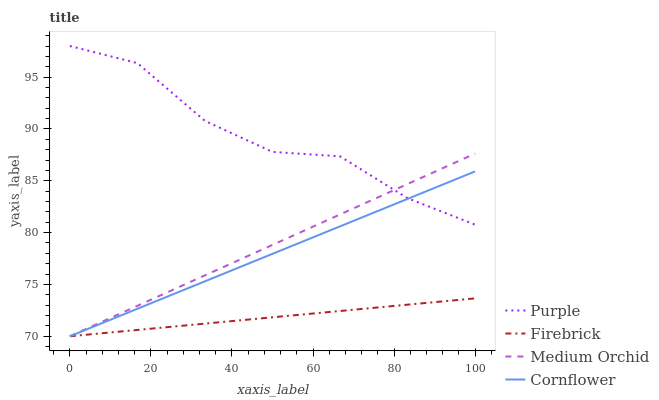Does Firebrick have the minimum area under the curve?
Answer yes or no. Yes. Does Purple have the maximum area under the curve?
Answer yes or no. Yes. Does Cornflower have the minimum area under the curve?
Answer yes or no. No. Does Cornflower have the maximum area under the curve?
Answer yes or no. No. Is Cornflower the smoothest?
Answer yes or no. Yes. Is Purple the roughest?
Answer yes or no. Yes. Is Firebrick the smoothest?
Answer yes or no. No. Is Firebrick the roughest?
Answer yes or no. No. Does Cornflower have the lowest value?
Answer yes or no. Yes. Does Purple have the highest value?
Answer yes or no. Yes. Does Cornflower have the highest value?
Answer yes or no. No. Is Firebrick less than Purple?
Answer yes or no. Yes. Is Purple greater than Firebrick?
Answer yes or no. Yes. Does Cornflower intersect Medium Orchid?
Answer yes or no. Yes. Is Cornflower less than Medium Orchid?
Answer yes or no. No. Is Cornflower greater than Medium Orchid?
Answer yes or no. No. Does Firebrick intersect Purple?
Answer yes or no. No. 